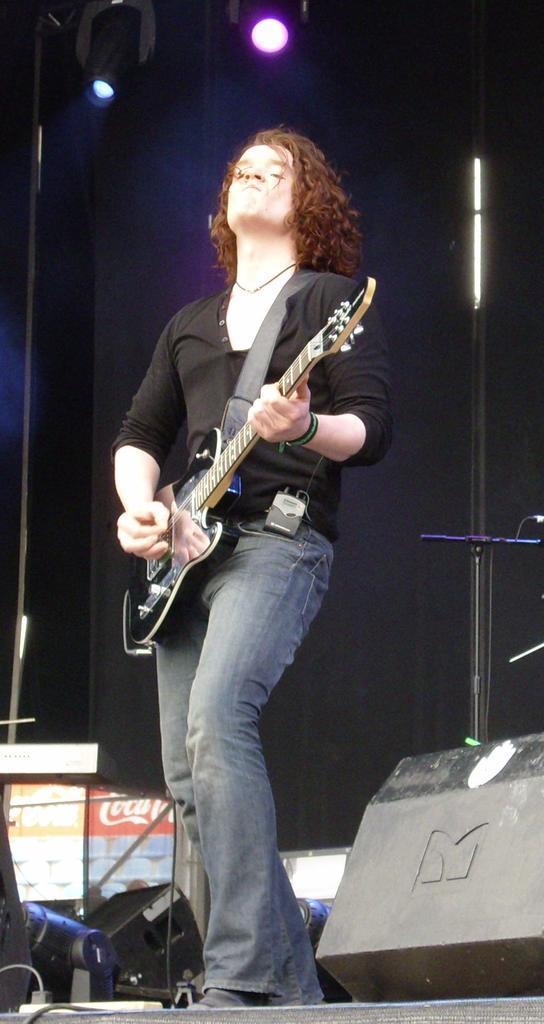Please provide a concise description of this image. In this picture i could see a person holding a guitar and moving the strings it seems like a stage performance in the back ground there is a black colored wall and a flash light. 